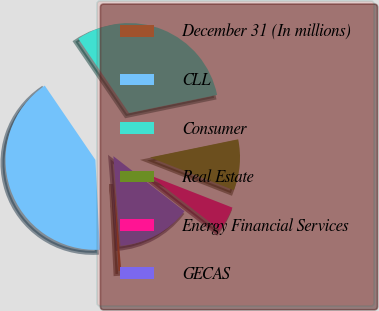Convert chart to OTSL. <chart><loc_0><loc_0><loc_500><loc_500><pie_chart><fcel>December 31 (In millions)<fcel>CLL<fcel>Consumer<fcel>Real Estate<fcel>Energy Financial Services<fcel>GECAS<nl><fcel>0.48%<fcel>41.26%<fcel>31.29%<fcel>9.17%<fcel>4.55%<fcel>13.25%<nl></chart> 